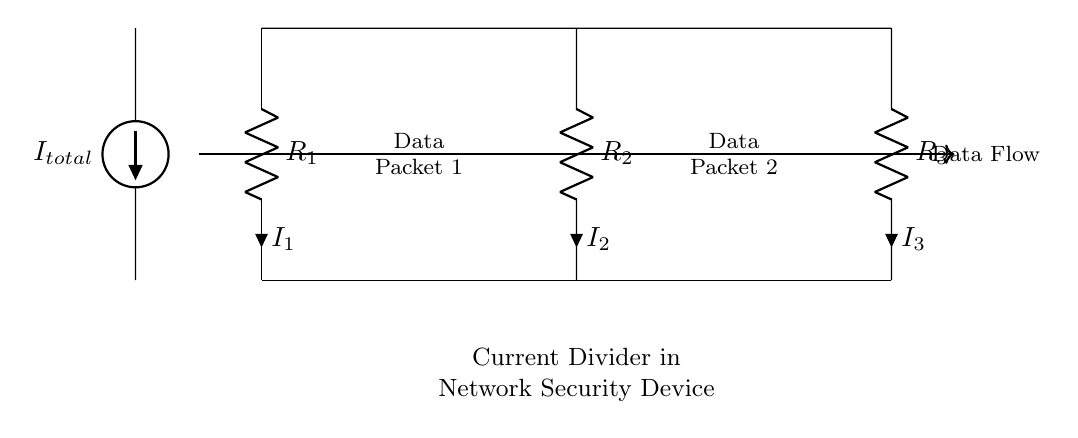What is the total current in this circuit? The total current, noted as I_total, is represented by the current source on the left of the diagram. It is the input current providing the supply for the entire current divider circuit.
Answer: I_total What are the resistance values in the circuit? The circuit contains three resistors: R_1, R_2, and R_3. The values of these resistors are typically represented with numbers associated in actual applications, but specifically, they are labeled R_1, R_2, and R_3 in this diagram.
Answer: R_1, R_2, R_3 Which resistor carries the most current? To determine which resistor carries the most current, one must apply the current divider rule: I_2 can be calculated based on the values of R_1 and R_3 in comparison. Generally, the current will divide in inverse relation to resistance. If R_2 is the least resistant, it will carry the most current.
Answer: R_2 What is the purpose of this circuit within a network security device? This circuit analyzes data packet flow by dividing the total current into parts based on the resistors, allowing for monitoring various data packets for threats or irregularities in a network.
Answer: Analyze data packet flow How can you calculate the current through R_2? The current through R_2 can be determined using the formula: I_2 = I_total * (R_total/R_2), where R_total is the combined resistance of the other resistors connected in parallel to R_2. This uses the property that the current is inversely proportional to the resistance.
Answer: I_2 = I_total * (R_total/R_2) What does the arrow indicate in this circuit diagram? The thick arrow represents the direction of data flow, indicating how the data packets are processed through the current divider circuit.
Answer: Data flow direction 